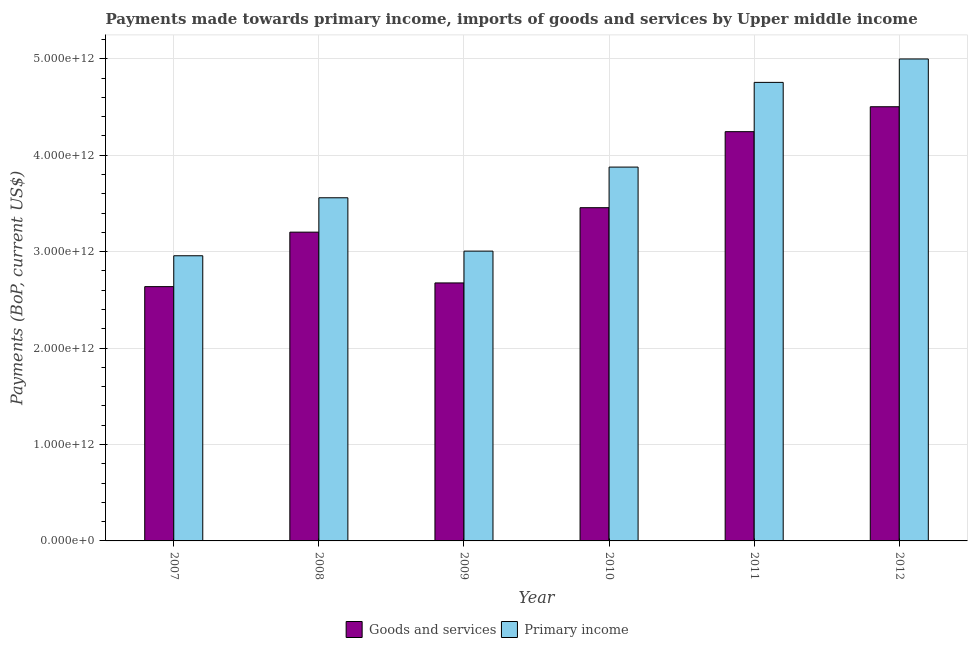How many different coloured bars are there?
Your response must be concise. 2. How many groups of bars are there?
Provide a succinct answer. 6. Are the number of bars on each tick of the X-axis equal?
Make the answer very short. Yes. How many bars are there on the 6th tick from the right?
Offer a very short reply. 2. What is the label of the 6th group of bars from the left?
Ensure brevity in your answer.  2012. What is the payments made towards goods and services in 2010?
Provide a succinct answer. 3.46e+12. Across all years, what is the maximum payments made towards primary income?
Make the answer very short. 5.00e+12. Across all years, what is the minimum payments made towards primary income?
Make the answer very short. 2.96e+12. In which year was the payments made towards goods and services maximum?
Give a very brief answer. 2012. In which year was the payments made towards primary income minimum?
Ensure brevity in your answer.  2007. What is the total payments made towards goods and services in the graph?
Your answer should be very brief. 2.07e+13. What is the difference between the payments made towards primary income in 2007 and that in 2012?
Your response must be concise. -2.04e+12. What is the difference between the payments made towards primary income in 2011 and the payments made towards goods and services in 2008?
Keep it short and to the point. 1.20e+12. What is the average payments made towards goods and services per year?
Offer a terse response. 3.45e+12. In how many years, is the payments made towards primary income greater than 3200000000000 US$?
Offer a very short reply. 4. What is the ratio of the payments made towards goods and services in 2007 to that in 2011?
Offer a terse response. 0.62. What is the difference between the highest and the second highest payments made towards primary income?
Your response must be concise. 2.43e+11. What is the difference between the highest and the lowest payments made towards goods and services?
Your response must be concise. 1.87e+12. In how many years, is the payments made towards goods and services greater than the average payments made towards goods and services taken over all years?
Give a very brief answer. 3. What does the 2nd bar from the left in 2011 represents?
Offer a very short reply. Primary income. What does the 1st bar from the right in 2010 represents?
Offer a terse response. Primary income. How many bars are there?
Make the answer very short. 12. Are all the bars in the graph horizontal?
Offer a very short reply. No. What is the difference between two consecutive major ticks on the Y-axis?
Offer a terse response. 1.00e+12. Does the graph contain any zero values?
Your answer should be compact. No. Does the graph contain grids?
Give a very brief answer. Yes. How are the legend labels stacked?
Provide a succinct answer. Horizontal. What is the title of the graph?
Provide a succinct answer. Payments made towards primary income, imports of goods and services by Upper middle income. Does "IMF concessional" appear as one of the legend labels in the graph?
Offer a terse response. No. What is the label or title of the Y-axis?
Your answer should be compact. Payments (BoP, current US$). What is the Payments (BoP, current US$) in Goods and services in 2007?
Your response must be concise. 2.64e+12. What is the Payments (BoP, current US$) in Primary income in 2007?
Ensure brevity in your answer.  2.96e+12. What is the Payments (BoP, current US$) in Goods and services in 2008?
Your answer should be compact. 3.20e+12. What is the Payments (BoP, current US$) in Primary income in 2008?
Keep it short and to the point. 3.56e+12. What is the Payments (BoP, current US$) of Goods and services in 2009?
Give a very brief answer. 2.68e+12. What is the Payments (BoP, current US$) of Primary income in 2009?
Your response must be concise. 3.01e+12. What is the Payments (BoP, current US$) in Goods and services in 2010?
Give a very brief answer. 3.46e+12. What is the Payments (BoP, current US$) of Primary income in 2010?
Give a very brief answer. 3.88e+12. What is the Payments (BoP, current US$) in Goods and services in 2011?
Offer a very short reply. 4.24e+12. What is the Payments (BoP, current US$) of Primary income in 2011?
Ensure brevity in your answer.  4.76e+12. What is the Payments (BoP, current US$) in Goods and services in 2012?
Offer a terse response. 4.50e+12. What is the Payments (BoP, current US$) of Primary income in 2012?
Keep it short and to the point. 5.00e+12. Across all years, what is the maximum Payments (BoP, current US$) of Goods and services?
Provide a succinct answer. 4.50e+12. Across all years, what is the maximum Payments (BoP, current US$) in Primary income?
Your answer should be compact. 5.00e+12. Across all years, what is the minimum Payments (BoP, current US$) in Goods and services?
Keep it short and to the point. 2.64e+12. Across all years, what is the minimum Payments (BoP, current US$) in Primary income?
Make the answer very short. 2.96e+12. What is the total Payments (BoP, current US$) of Goods and services in the graph?
Your response must be concise. 2.07e+13. What is the total Payments (BoP, current US$) of Primary income in the graph?
Provide a succinct answer. 2.32e+13. What is the difference between the Payments (BoP, current US$) in Goods and services in 2007 and that in 2008?
Make the answer very short. -5.65e+11. What is the difference between the Payments (BoP, current US$) in Primary income in 2007 and that in 2008?
Ensure brevity in your answer.  -6.01e+11. What is the difference between the Payments (BoP, current US$) of Goods and services in 2007 and that in 2009?
Give a very brief answer. -3.83e+1. What is the difference between the Payments (BoP, current US$) in Primary income in 2007 and that in 2009?
Your response must be concise. -4.81e+1. What is the difference between the Payments (BoP, current US$) of Goods and services in 2007 and that in 2010?
Offer a very short reply. -8.19e+11. What is the difference between the Payments (BoP, current US$) in Primary income in 2007 and that in 2010?
Provide a short and direct response. -9.20e+11. What is the difference between the Payments (BoP, current US$) of Goods and services in 2007 and that in 2011?
Provide a short and direct response. -1.61e+12. What is the difference between the Payments (BoP, current US$) of Primary income in 2007 and that in 2011?
Offer a very short reply. -1.80e+12. What is the difference between the Payments (BoP, current US$) of Goods and services in 2007 and that in 2012?
Offer a very short reply. -1.87e+12. What is the difference between the Payments (BoP, current US$) in Primary income in 2007 and that in 2012?
Provide a succinct answer. -2.04e+12. What is the difference between the Payments (BoP, current US$) in Goods and services in 2008 and that in 2009?
Give a very brief answer. 5.27e+11. What is the difference between the Payments (BoP, current US$) of Primary income in 2008 and that in 2009?
Ensure brevity in your answer.  5.53e+11. What is the difference between the Payments (BoP, current US$) in Goods and services in 2008 and that in 2010?
Make the answer very short. -2.54e+11. What is the difference between the Payments (BoP, current US$) in Primary income in 2008 and that in 2010?
Your response must be concise. -3.18e+11. What is the difference between the Payments (BoP, current US$) of Goods and services in 2008 and that in 2011?
Keep it short and to the point. -1.04e+12. What is the difference between the Payments (BoP, current US$) of Primary income in 2008 and that in 2011?
Provide a succinct answer. -1.20e+12. What is the difference between the Payments (BoP, current US$) of Goods and services in 2008 and that in 2012?
Your answer should be very brief. -1.30e+12. What is the difference between the Payments (BoP, current US$) of Primary income in 2008 and that in 2012?
Make the answer very short. -1.44e+12. What is the difference between the Payments (BoP, current US$) of Goods and services in 2009 and that in 2010?
Your answer should be compact. -7.80e+11. What is the difference between the Payments (BoP, current US$) in Primary income in 2009 and that in 2010?
Provide a short and direct response. -8.71e+11. What is the difference between the Payments (BoP, current US$) in Goods and services in 2009 and that in 2011?
Your answer should be very brief. -1.57e+12. What is the difference between the Payments (BoP, current US$) of Primary income in 2009 and that in 2011?
Offer a terse response. -1.75e+12. What is the difference between the Payments (BoP, current US$) of Goods and services in 2009 and that in 2012?
Ensure brevity in your answer.  -1.83e+12. What is the difference between the Payments (BoP, current US$) of Primary income in 2009 and that in 2012?
Keep it short and to the point. -1.99e+12. What is the difference between the Payments (BoP, current US$) in Goods and services in 2010 and that in 2011?
Your answer should be very brief. -7.88e+11. What is the difference between the Payments (BoP, current US$) of Primary income in 2010 and that in 2011?
Your answer should be very brief. -8.78e+11. What is the difference between the Payments (BoP, current US$) of Goods and services in 2010 and that in 2012?
Offer a terse response. -1.05e+12. What is the difference between the Payments (BoP, current US$) of Primary income in 2010 and that in 2012?
Ensure brevity in your answer.  -1.12e+12. What is the difference between the Payments (BoP, current US$) of Goods and services in 2011 and that in 2012?
Ensure brevity in your answer.  -2.58e+11. What is the difference between the Payments (BoP, current US$) of Primary income in 2011 and that in 2012?
Offer a terse response. -2.43e+11. What is the difference between the Payments (BoP, current US$) of Goods and services in 2007 and the Payments (BoP, current US$) of Primary income in 2008?
Provide a short and direct response. -9.21e+11. What is the difference between the Payments (BoP, current US$) in Goods and services in 2007 and the Payments (BoP, current US$) in Primary income in 2009?
Ensure brevity in your answer.  -3.68e+11. What is the difference between the Payments (BoP, current US$) in Goods and services in 2007 and the Payments (BoP, current US$) in Primary income in 2010?
Offer a very short reply. -1.24e+12. What is the difference between the Payments (BoP, current US$) in Goods and services in 2007 and the Payments (BoP, current US$) in Primary income in 2011?
Your answer should be compact. -2.12e+12. What is the difference between the Payments (BoP, current US$) of Goods and services in 2007 and the Payments (BoP, current US$) of Primary income in 2012?
Your response must be concise. -2.36e+12. What is the difference between the Payments (BoP, current US$) in Goods and services in 2008 and the Payments (BoP, current US$) in Primary income in 2009?
Your answer should be very brief. 1.97e+11. What is the difference between the Payments (BoP, current US$) of Goods and services in 2008 and the Payments (BoP, current US$) of Primary income in 2010?
Provide a short and direct response. -6.75e+11. What is the difference between the Payments (BoP, current US$) in Goods and services in 2008 and the Payments (BoP, current US$) in Primary income in 2011?
Provide a short and direct response. -1.55e+12. What is the difference between the Payments (BoP, current US$) in Goods and services in 2008 and the Payments (BoP, current US$) in Primary income in 2012?
Provide a succinct answer. -1.80e+12. What is the difference between the Payments (BoP, current US$) of Goods and services in 2009 and the Payments (BoP, current US$) of Primary income in 2010?
Provide a succinct answer. -1.20e+12. What is the difference between the Payments (BoP, current US$) in Goods and services in 2009 and the Payments (BoP, current US$) in Primary income in 2011?
Provide a short and direct response. -2.08e+12. What is the difference between the Payments (BoP, current US$) of Goods and services in 2009 and the Payments (BoP, current US$) of Primary income in 2012?
Your answer should be very brief. -2.32e+12. What is the difference between the Payments (BoP, current US$) in Goods and services in 2010 and the Payments (BoP, current US$) in Primary income in 2011?
Your response must be concise. -1.30e+12. What is the difference between the Payments (BoP, current US$) of Goods and services in 2010 and the Payments (BoP, current US$) of Primary income in 2012?
Offer a terse response. -1.54e+12. What is the difference between the Payments (BoP, current US$) of Goods and services in 2011 and the Payments (BoP, current US$) of Primary income in 2012?
Make the answer very short. -7.54e+11. What is the average Payments (BoP, current US$) in Goods and services per year?
Provide a succinct answer. 3.45e+12. What is the average Payments (BoP, current US$) in Primary income per year?
Your response must be concise. 3.86e+12. In the year 2007, what is the difference between the Payments (BoP, current US$) of Goods and services and Payments (BoP, current US$) of Primary income?
Give a very brief answer. -3.20e+11. In the year 2008, what is the difference between the Payments (BoP, current US$) of Goods and services and Payments (BoP, current US$) of Primary income?
Your response must be concise. -3.56e+11. In the year 2009, what is the difference between the Payments (BoP, current US$) in Goods and services and Payments (BoP, current US$) in Primary income?
Provide a short and direct response. -3.30e+11. In the year 2010, what is the difference between the Payments (BoP, current US$) in Goods and services and Payments (BoP, current US$) in Primary income?
Provide a short and direct response. -4.21e+11. In the year 2011, what is the difference between the Payments (BoP, current US$) in Goods and services and Payments (BoP, current US$) in Primary income?
Your response must be concise. -5.11e+11. In the year 2012, what is the difference between the Payments (BoP, current US$) in Goods and services and Payments (BoP, current US$) in Primary income?
Provide a succinct answer. -4.95e+11. What is the ratio of the Payments (BoP, current US$) in Goods and services in 2007 to that in 2008?
Offer a terse response. 0.82. What is the ratio of the Payments (BoP, current US$) in Primary income in 2007 to that in 2008?
Keep it short and to the point. 0.83. What is the ratio of the Payments (BoP, current US$) in Goods and services in 2007 to that in 2009?
Ensure brevity in your answer.  0.99. What is the ratio of the Payments (BoP, current US$) of Goods and services in 2007 to that in 2010?
Ensure brevity in your answer.  0.76. What is the ratio of the Payments (BoP, current US$) in Primary income in 2007 to that in 2010?
Your answer should be very brief. 0.76. What is the ratio of the Payments (BoP, current US$) of Goods and services in 2007 to that in 2011?
Provide a short and direct response. 0.62. What is the ratio of the Payments (BoP, current US$) of Primary income in 2007 to that in 2011?
Offer a terse response. 0.62. What is the ratio of the Payments (BoP, current US$) in Goods and services in 2007 to that in 2012?
Your answer should be compact. 0.59. What is the ratio of the Payments (BoP, current US$) of Primary income in 2007 to that in 2012?
Keep it short and to the point. 0.59. What is the ratio of the Payments (BoP, current US$) in Goods and services in 2008 to that in 2009?
Offer a very short reply. 1.2. What is the ratio of the Payments (BoP, current US$) of Primary income in 2008 to that in 2009?
Make the answer very short. 1.18. What is the ratio of the Payments (BoP, current US$) in Goods and services in 2008 to that in 2010?
Offer a terse response. 0.93. What is the ratio of the Payments (BoP, current US$) of Primary income in 2008 to that in 2010?
Provide a short and direct response. 0.92. What is the ratio of the Payments (BoP, current US$) in Goods and services in 2008 to that in 2011?
Provide a succinct answer. 0.75. What is the ratio of the Payments (BoP, current US$) of Primary income in 2008 to that in 2011?
Keep it short and to the point. 0.75. What is the ratio of the Payments (BoP, current US$) in Goods and services in 2008 to that in 2012?
Keep it short and to the point. 0.71. What is the ratio of the Payments (BoP, current US$) in Primary income in 2008 to that in 2012?
Keep it short and to the point. 0.71. What is the ratio of the Payments (BoP, current US$) of Goods and services in 2009 to that in 2010?
Give a very brief answer. 0.77. What is the ratio of the Payments (BoP, current US$) of Primary income in 2009 to that in 2010?
Provide a short and direct response. 0.78. What is the ratio of the Payments (BoP, current US$) of Goods and services in 2009 to that in 2011?
Ensure brevity in your answer.  0.63. What is the ratio of the Payments (BoP, current US$) in Primary income in 2009 to that in 2011?
Give a very brief answer. 0.63. What is the ratio of the Payments (BoP, current US$) in Goods and services in 2009 to that in 2012?
Provide a succinct answer. 0.59. What is the ratio of the Payments (BoP, current US$) of Primary income in 2009 to that in 2012?
Keep it short and to the point. 0.6. What is the ratio of the Payments (BoP, current US$) in Goods and services in 2010 to that in 2011?
Keep it short and to the point. 0.81. What is the ratio of the Payments (BoP, current US$) of Primary income in 2010 to that in 2011?
Your answer should be very brief. 0.82. What is the ratio of the Payments (BoP, current US$) of Goods and services in 2010 to that in 2012?
Provide a succinct answer. 0.77. What is the ratio of the Payments (BoP, current US$) in Primary income in 2010 to that in 2012?
Make the answer very short. 0.78. What is the ratio of the Payments (BoP, current US$) in Goods and services in 2011 to that in 2012?
Offer a terse response. 0.94. What is the ratio of the Payments (BoP, current US$) in Primary income in 2011 to that in 2012?
Your answer should be compact. 0.95. What is the difference between the highest and the second highest Payments (BoP, current US$) in Goods and services?
Your answer should be very brief. 2.58e+11. What is the difference between the highest and the second highest Payments (BoP, current US$) in Primary income?
Offer a very short reply. 2.43e+11. What is the difference between the highest and the lowest Payments (BoP, current US$) in Goods and services?
Make the answer very short. 1.87e+12. What is the difference between the highest and the lowest Payments (BoP, current US$) in Primary income?
Make the answer very short. 2.04e+12. 